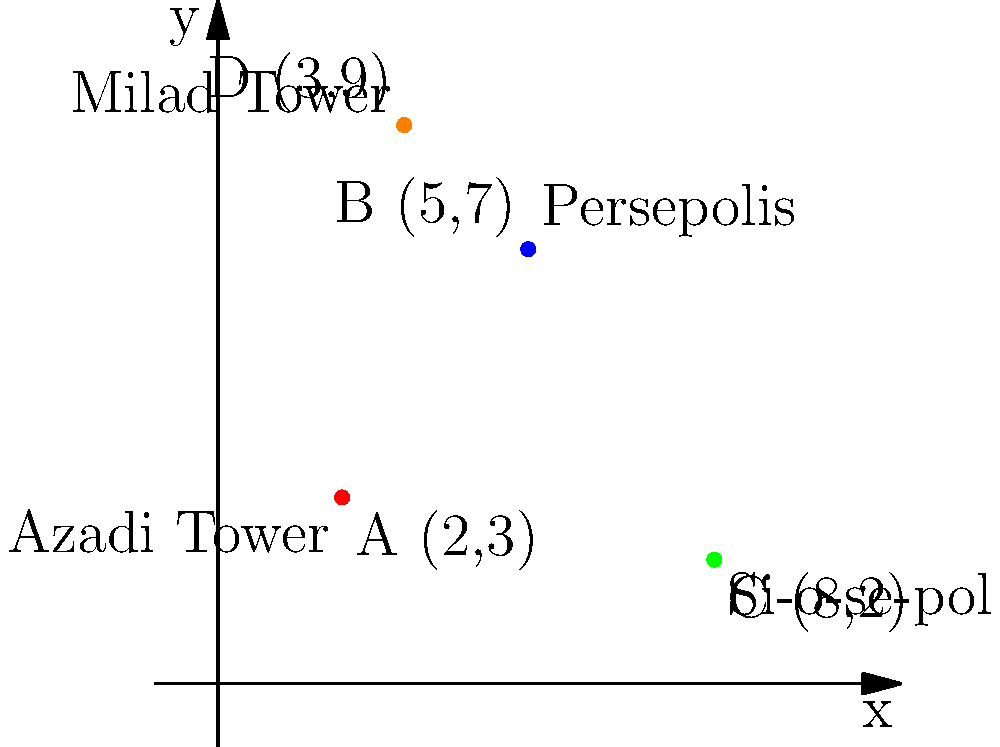On the coordinate plane above, four famous Iranian landmarks are represented by points A, B, C, and D. If you were to travel from the Azadi Tower to Persepolis, then to the Si-o-se-pol bridge, and finally to the Milad Tower, what would be the total distance traveled? (Round your answer to the nearest whole number.) To solve this problem, we need to calculate the distances between the points and sum them up. We'll use the distance formula: $d = \sqrt{(x_2-x_1)^2 + (y_2-y_1)^2}$

1. Distance from Azadi Tower (A) to Persepolis (B):
   $d_{AB} = \sqrt{(5-2)^2 + (7-3)^2} = \sqrt{3^2 + 4^2} = \sqrt{25} = 5$

2. Distance from Persepolis (B) to Si-o-se-pol (C):
   $d_{BC} = \sqrt{(8-5)^2 + (2-7)^2} = \sqrt{3^2 + (-5)^2} = \sqrt{34} \approx 5.83$

3. Distance from Si-o-se-pol (C) to Milad Tower (D):
   $d_{CD} = \sqrt{(3-8)^2 + (9-2)^2} = \sqrt{(-5)^2 + 7^2} = \sqrt{74} \approx 8.60$

4. Total distance:
   $d_{total} = d_{AB} + d_{BC} + d_{CD} = 5 + 5.83 + 8.60 = 19.43$

5. Rounding to the nearest whole number:
   $19.43 \approx 19$

Therefore, the total distance traveled is approximately 19 units.
Answer: 19 units 